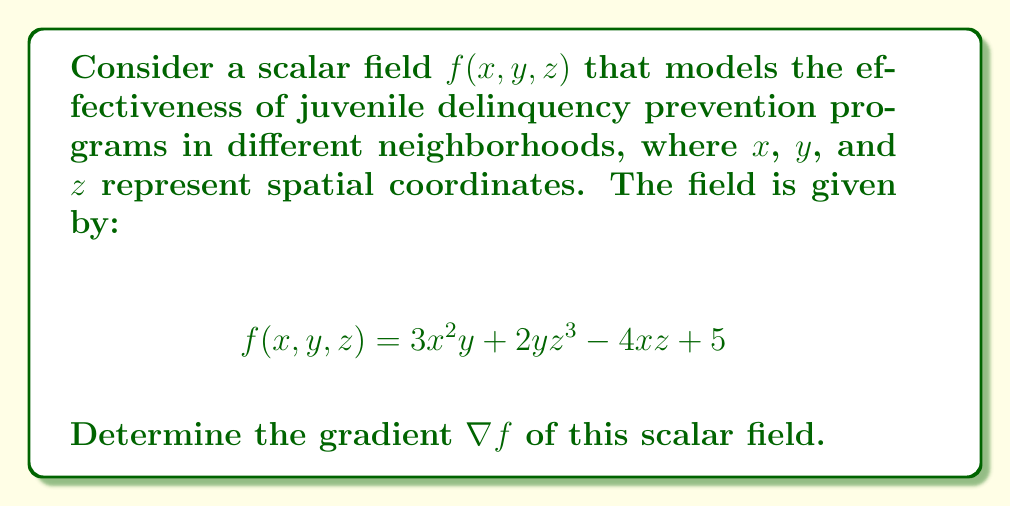Help me with this question. To find the gradient of the scalar field, we need to calculate the partial derivatives with respect to each variable:

1. Calculate $\frac{\partial f}{\partial x}$:
   $$\frac{\partial f}{\partial x} = \frac{\partial}{\partial x}(3x^2y + 2yz^3 - 4xz + 5) = 6xy - 4z$$

2. Calculate $\frac{\partial f}{\partial y}$:
   $$\frac{\partial f}{\partial y} = \frac{\partial}{\partial y}(3x^2y + 2yz^3 - 4xz + 5) = 3x^2 + 2z^3$$

3. Calculate $\frac{\partial f}{\partial z}$:
   $$\frac{\partial f}{\partial z} = \frac{\partial}{\partial z}(3x^2y + 2yz^3 - 4xz + 5) = 6yz^2 - 4x$$

4. The gradient is defined as:
   $$\nabla f = \left(\frac{\partial f}{\partial x}, \frac{\partial f}{\partial y}, \frac{\partial f}{\partial z}\right)$$

5. Substituting the partial derivatives:
   $$\nabla f = (6xy - 4z, 3x^2 + 2z^3, 6yz^2 - 4x)$$
Answer: $\nabla f = (6xy - 4z, 3x^2 + 2z^3, 6yz^2 - 4x)$ 